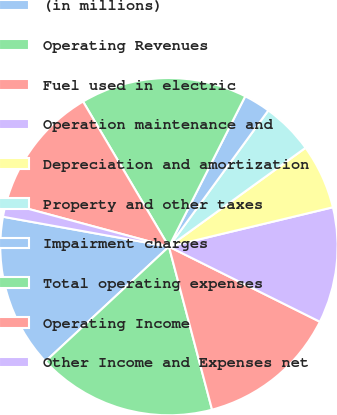Convert chart to OTSL. <chart><loc_0><loc_0><loc_500><loc_500><pie_chart><fcel>(in millions)<fcel>Operating Revenues<fcel>Fuel used in electric<fcel>Operation maintenance and<fcel>Depreciation and amortization<fcel>Property and other taxes<fcel>Impairment charges<fcel>Total operating expenses<fcel>Operating Income<fcel>Other Income and Expenses net<nl><fcel>14.76%<fcel>17.2%<fcel>13.54%<fcel>11.1%<fcel>6.22%<fcel>5.0%<fcel>2.56%<fcel>15.98%<fcel>12.32%<fcel>1.34%<nl></chart> 